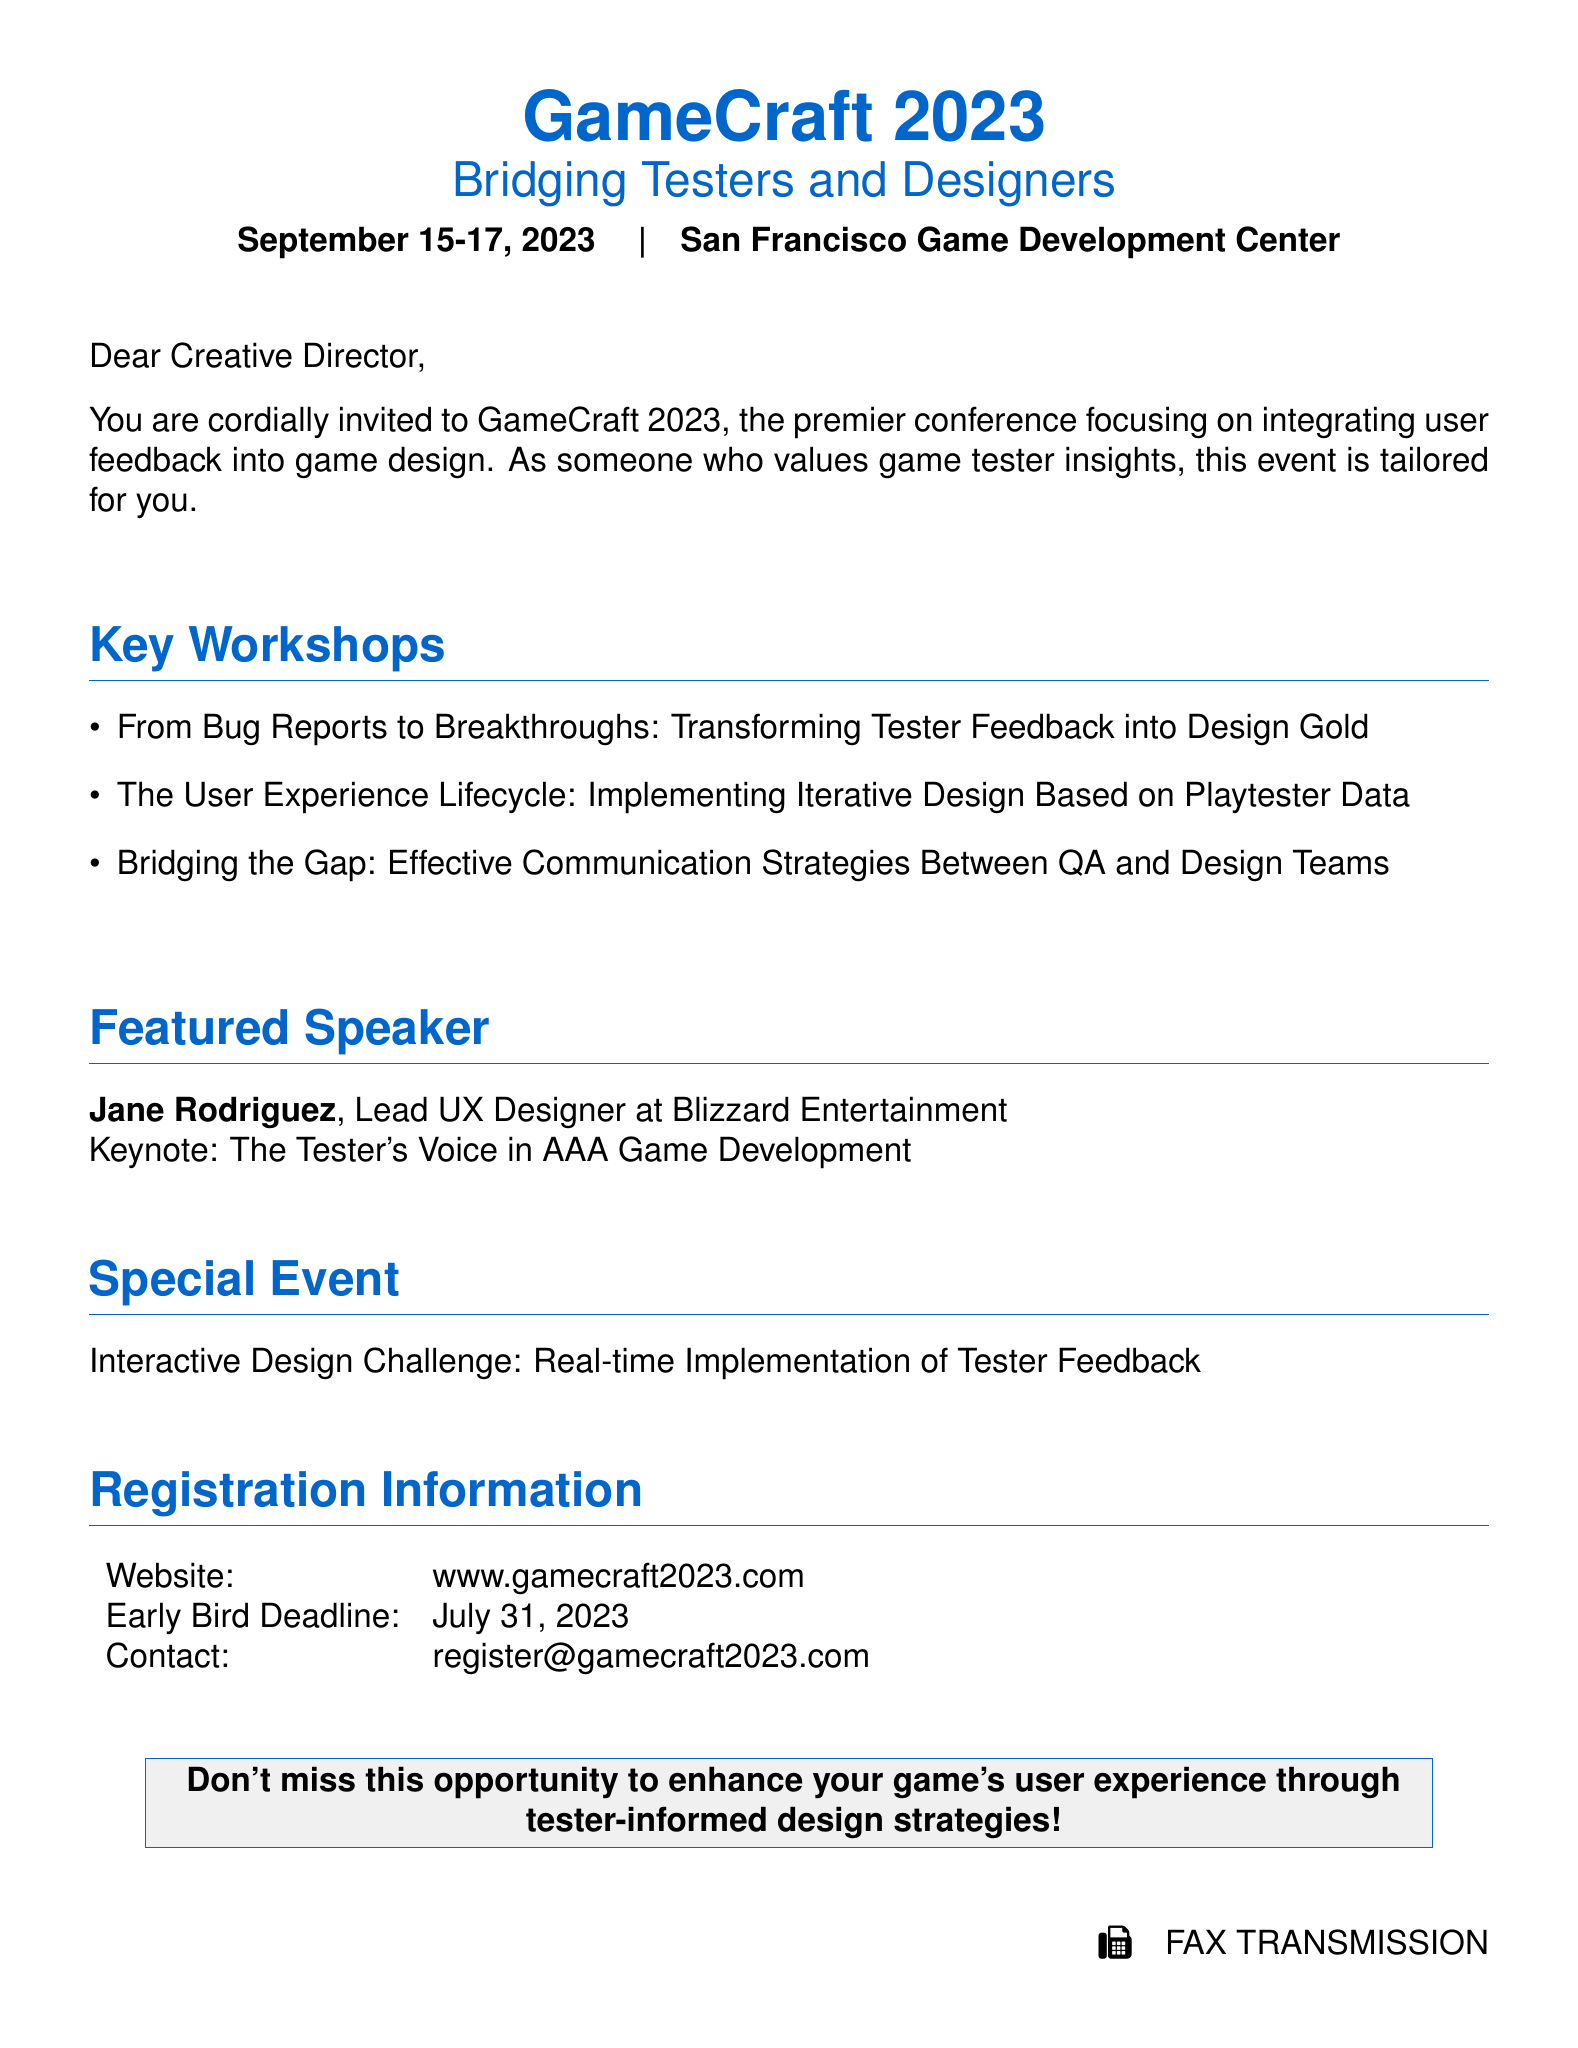What is the name of the conference? The name of the conference is featured prominently at the top of the document.
Answer: GameCraft 2023 What is the theme of the conference? The theme is stated beneath the conference name, indicating its focus area.
Answer: Bridging Testers and Designers When will the conference take place? The date is clearly mentioned in the introductory section of the document.
Answer: September 15-17, 2023 Who is the featured speaker? The document lists the keynote speaker's name and position.
Answer: Jane Rodriguez What is the contact email for registration? The document provides specific contact information for registration inquiries.
Answer: register@gamecraft2023.com What is the early bird registration deadline? The deadline for early registration is clearly indicated in the registration information section.
Answer: July 31, 2023 What is the title of the keynote speech? The title of the keynote speech is mentioned next to the featured speaker's name.
Answer: The Tester's Voice in AAA Game Development What type of event is included as a special feature? The document describes an interactive event that focuses on practical application of feedback.
Answer: Interactive Design Challenge What is the website for the conference? The website address is provided in the registration information section.
Answer: www.gamecraft2023.com 